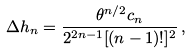<formula> <loc_0><loc_0><loc_500><loc_500>\Delta h _ { n } = \frac { \theta ^ { n / 2 } c _ { n } } { 2 ^ { 2 n - 1 } [ ( n - 1 ) ! ] ^ { 2 } } \, ,</formula> 